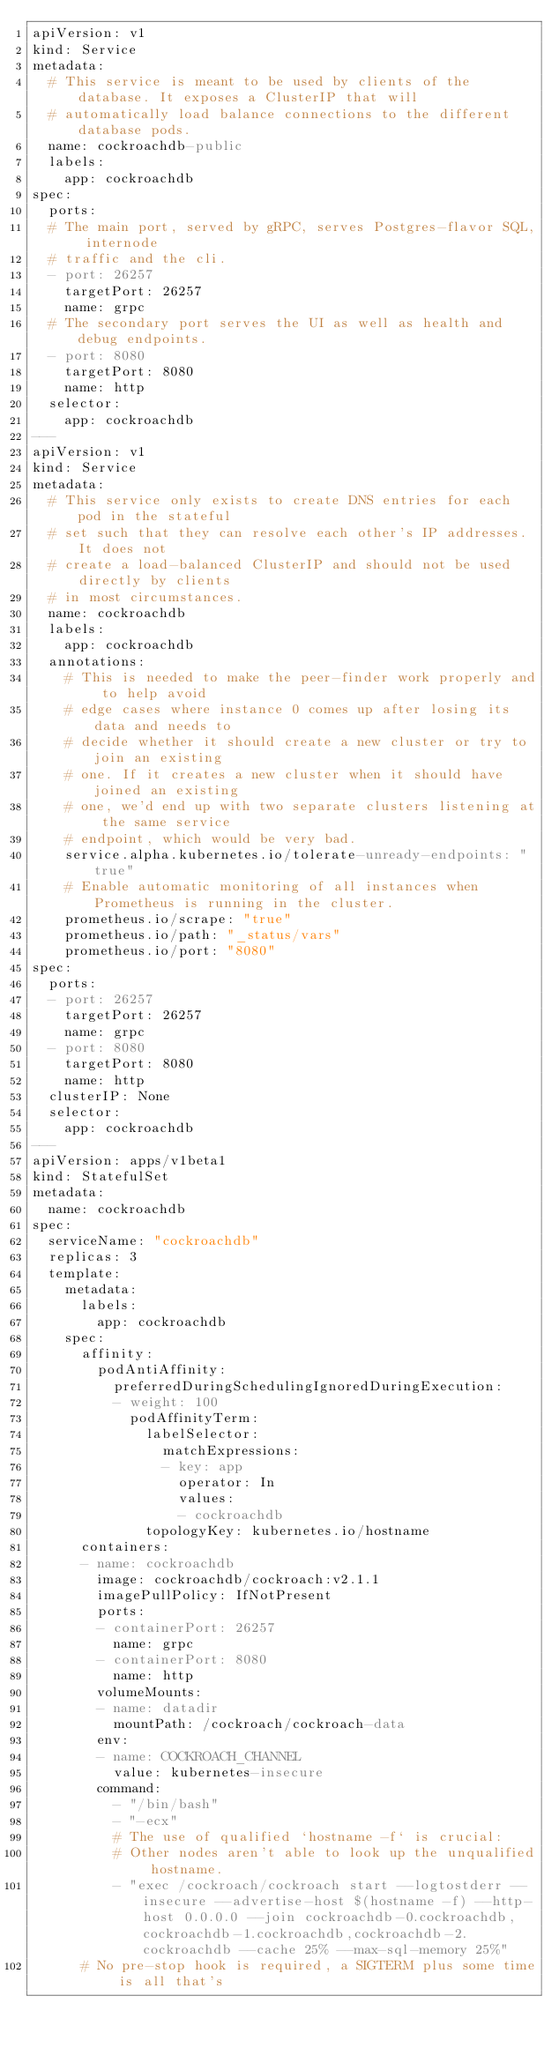Convert code to text. <code><loc_0><loc_0><loc_500><loc_500><_YAML_>apiVersion: v1
kind: Service
metadata:
  # This service is meant to be used by clients of the database. It exposes a ClusterIP that will
  # automatically load balance connections to the different database pods.
  name: cockroachdb-public
  labels:
    app: cockroachdb
spec:
  ports:
  # The main port, served by gRPC, serves Postgres-flavor SQL, internode
  # traffic and the cli.
  - port: 26257
    targetPort: 26257
    name: grpc
  # The secondary port serves the UI as well as health and debug endpoints.
  - port: 8080
    targetPort: 8080
    name: http
  selector:
    app: cockroachdb
---
apiVersion: v1
kind: Service
metadata:
  # This service only exists to create DNS entries for each pod in the stateful
  # set such that they can resolve each other's IP addresses. It does not
  # create a load-balanced ClusterIP and should not be used directly by clients
  # in most circumstances.
  name: cockroachdb
  labels:
    app: cockroachdb
  annotations:
    # This is needed to make the peer-finder work properly and to help avoid
    # edge cases where instance 0 comes up after losing its data and needs to
    # decide whether it should create a new cluster or try to join an existing
    # one. If it creates a new cluster when it should have joined an existing
    # one, we'd end up with two separate clusters listening at the same service
    # endpoint, which would be very bad.
    service.alpha.kubernetes.io/tolerate-unready-endpoints: "true"
    # Enable automatic monitoring of all instances when Prometheus is running in the cluster.
    prometheus.io/scrape: "true"
    prometheus.io/path: "_status/vars"
    prometheus.io/port: "8080"
spec:
  ports:
  - port: 26257
    targetPort: 26257
    name: grpc
  - port: 8080
    targetPort: 8080
    name: http
  clusterIP: None
  selector:
    app: cockroachdb
---
apiVersion: apps/v1beta1
kind: StatefulSet
metadata:
  name: cockroachdb
spec:
  serviceName: "cockroachdb"
  replicas: 3
  template:
    metadata:
      labels:
        app: cockroachdb
    spec:
      affinity:
        podAntiAffinity:
          preferredDuringSchedulingIgnoredDuringExecution:
          - weight: 100
            podAffinityTerm:
              labelSelector:
                matchExpressions:
                - key: app
                  operator: In
                  values:
                  - cockroachdb
              topologyKey: kubernetes.io/hostname
      containers:
      - name: cockroachdb
        image: cockroachdb/cockroach:v2.1.1
        imagePullPolicy: IfNotPresent
        ports:
        - containerPort: 26257
          name: grpc
        - containerPort: 8080
          name: http
        volumeMounts:
        - name: datadir
          mountPath: /cockroach/cockroach-data
        env:
        - name: COCKROACH_CHANNEL
          value: kubernetes-insecure
        command:
          - "/bin/bash"
          - "-ecx"
          # The use of qualified `hostname -f` is crucial:
          # Other nodes aren't able to look up the unqualified hostname.
          - "exec /cockroach/cockroach start --logtostderr --insecure --advertise-host $(hostname -f) --http-host 0.0.0.0 --join cockroachdb-0.cockroachdb,cockroachdb-1.cockroachdb,cockroachdb-2.cockroachdb --cache 25% --max-sql-memory 25%"
      # No pre-stop hook is required, a SIGTERM plus some time is all that's</code> 